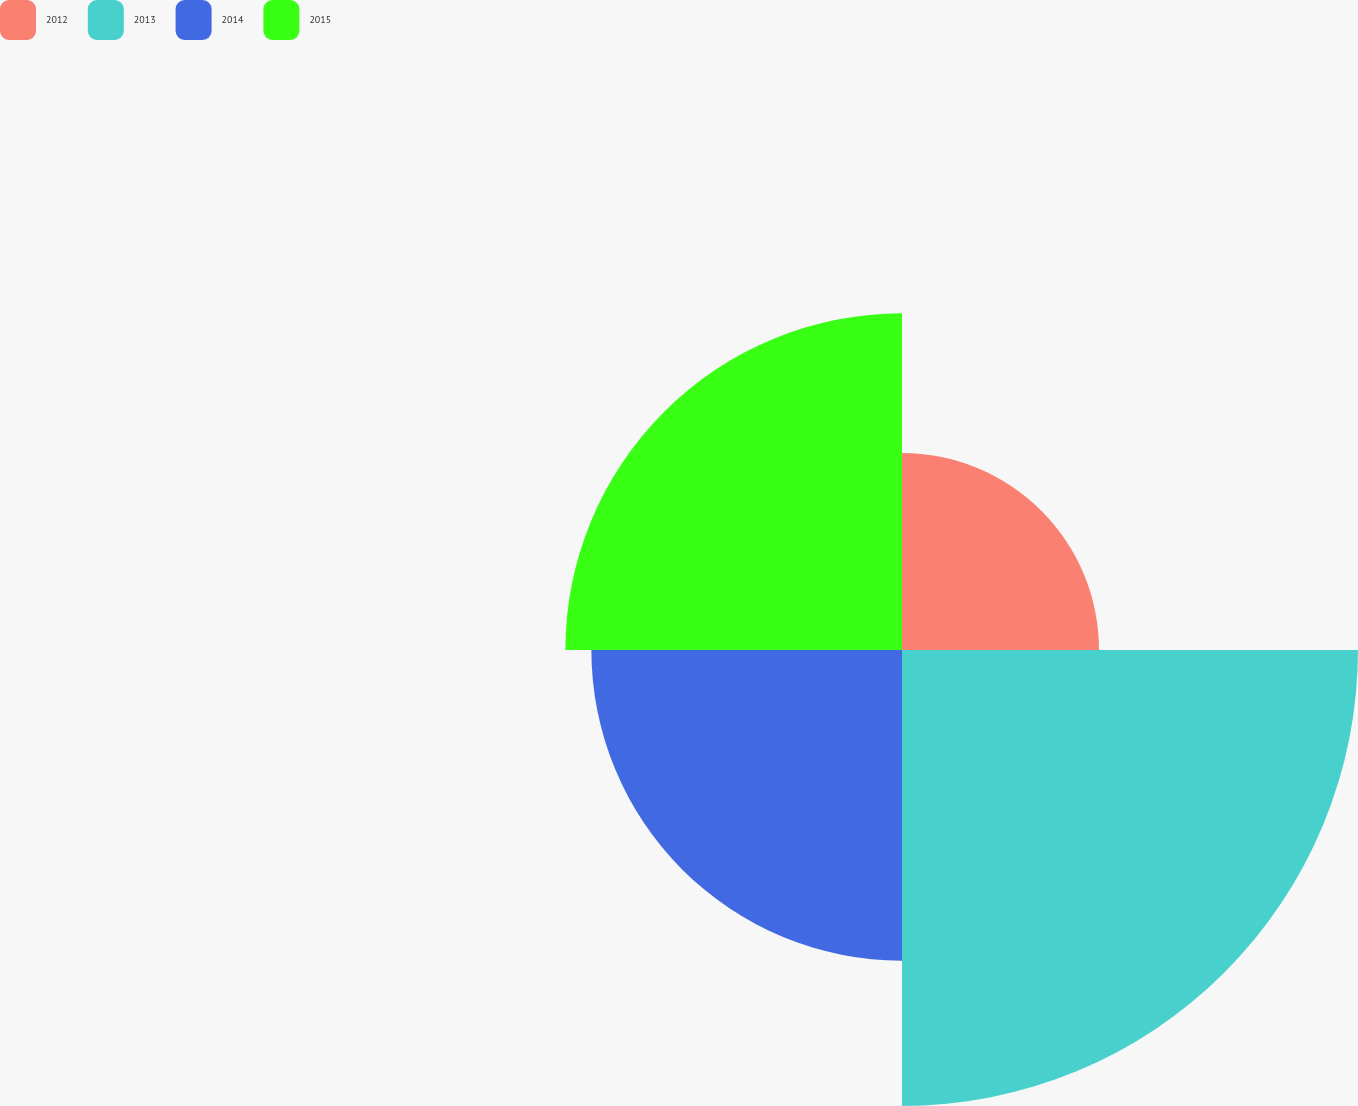Convert chart. <chart><loc_0><loc_0><loc_500><loc_500><pie_chart><fcel>2012<fcel>2013<fcel>2014<fcel>2015<nl><fcel>15.15%<fcel>35.07%<fcel>23.89%<fcel>25.89%<nl></chart> 